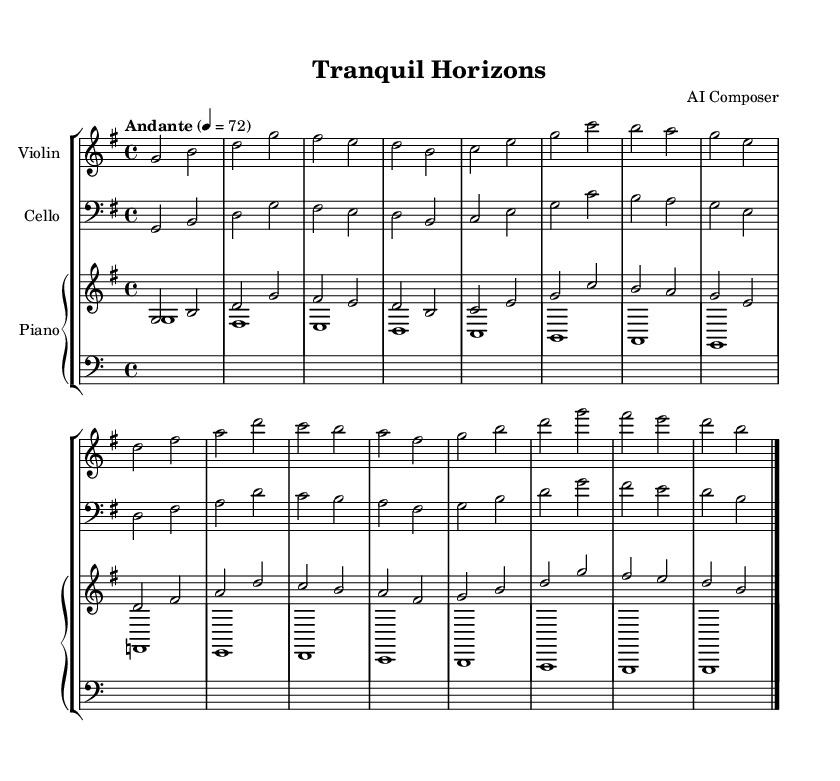What is the key signature of this music? The key signature shown at the beginning indicates G major, which has one sharp (F#). This can be identified by looking for the sharp symbol on the F line in the staff.
Answer: G major What is the time signature of this piece? The time signature is 4/4, indicated at the beginning of the score. This means there are four beats per measure and the quarter note gets one beat.
Answer: 4/4 What is the tempo marking for this piece? The tempo marking is "Andante," which suggests a moderate walking pace. This is indicated above the staff, along with the metronome marking of 72.
Answer: Andante How many measures are in the piece? By counting the bar lines in the sheet music, you can determine the total number of measures. There are four visible measures in each line, and there are four lines, which leads to a total of 16 measures.
Answer: 16 Which instruments are featured in this composition? The score includes a violin, a cello, and a piano. Each instrument is clearly labeled at the top of its respective staff.
Answer: Violin, cello, piano What is the texture of the music based on the score? The texture can be discerned by analyzing the interplay of the instruments. The piano has both right and left hand parts, while the violin and cello provide melodic and harmonic support, indicating a homophonic texture.
Answer: Homophonic 